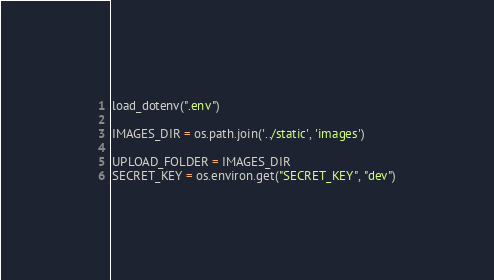Convert code to text. <code><loc_0><loc_0><loc_500><loc_500><_Python_>
load_dotenv(".env")

IMAGES_DIR = os.path.join('../static', 'images')

UPLOAD_FOLDER = IMAGES_DIR
SECRET_KEY = os.environ.get("SECRET_KEY", "dev")
</code> 